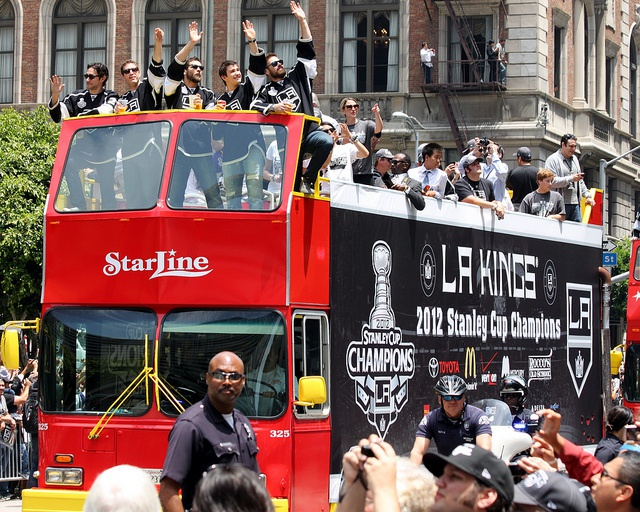Describe the objects in this image and their specific colors. I can see bus in black, red, white, and darkgray tones, people in black, gray, white, and brown tones, people in black, gray, and maroon tones, people in black and gray tones, and people in black, darkgray, gray, and lightgray tones in this image. 